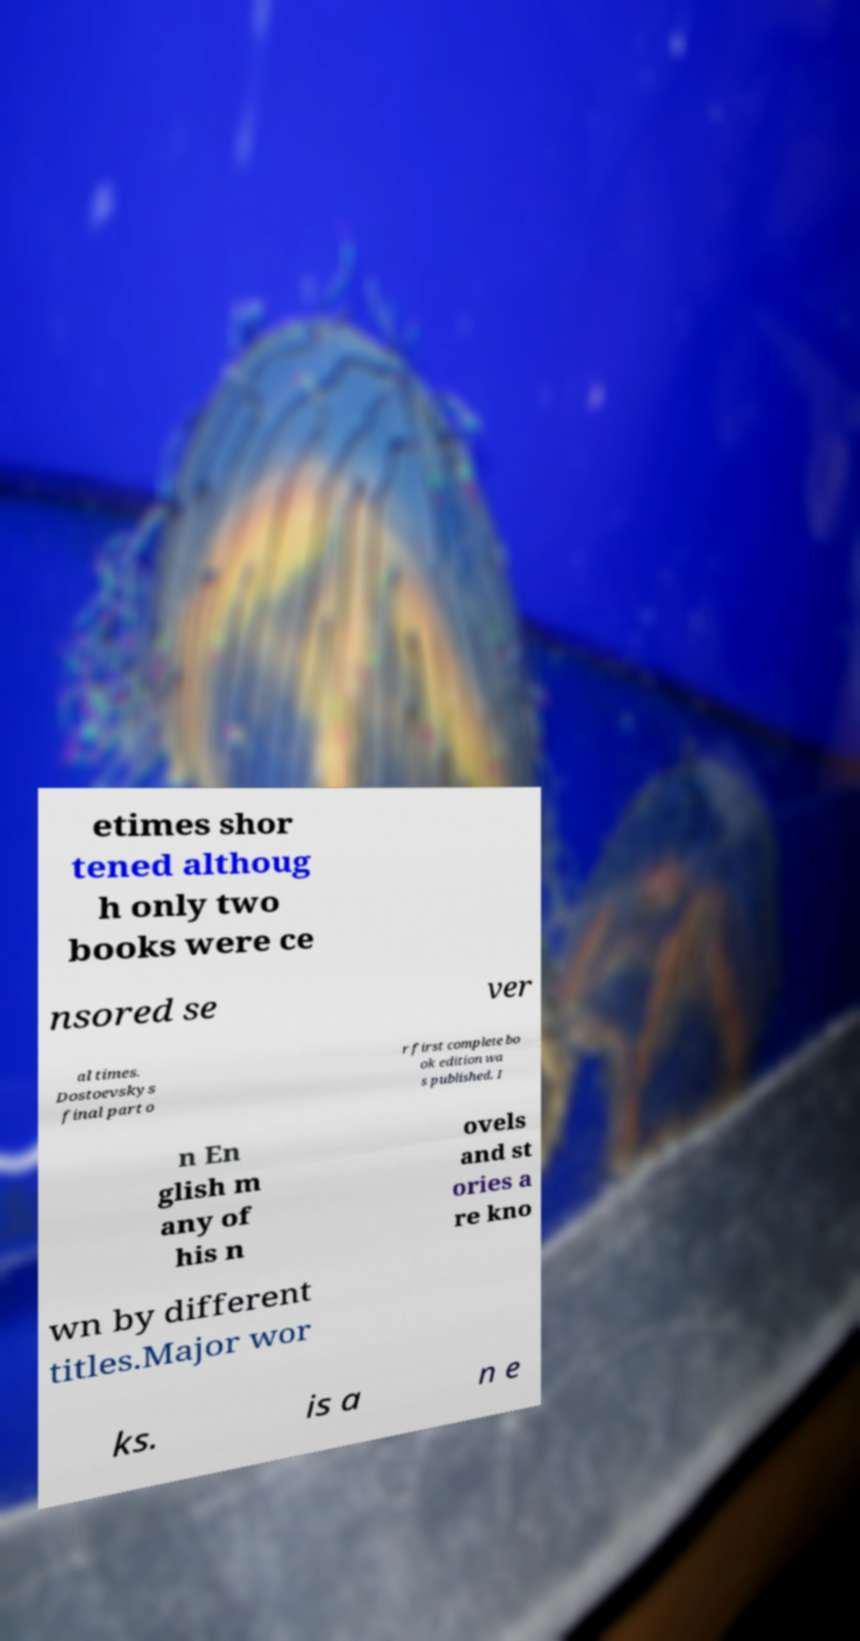Can you accurately transcribe the text from the provided image for me? etimes shor tened althoug h only two books were ce nsored se ver al times. Dostoevskys final part o r first complete bo ok edition wa s published. I n En glish m any of his n ovels and st ories a re kno wn by different titles.Major wor ks. is a n e 